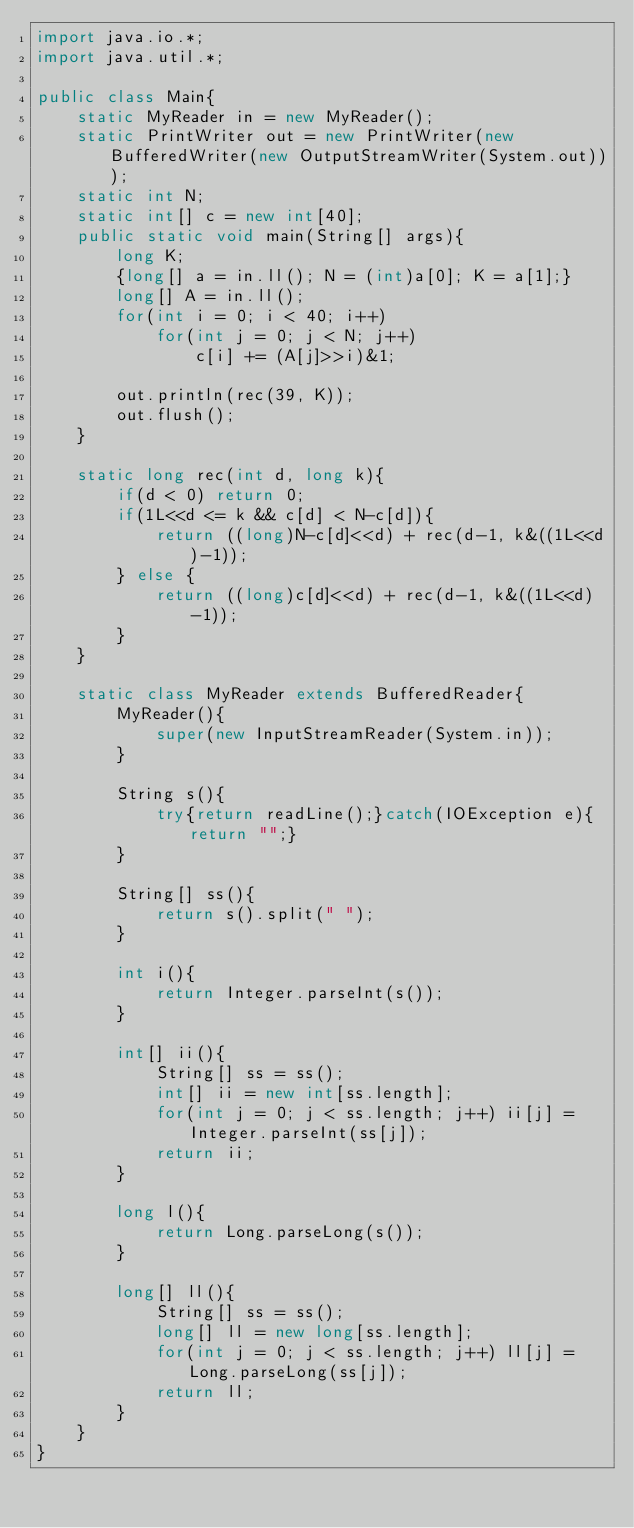<code> <loc_0><loc_0><loc_500><loc_500><_Java_>import java.io.*;
import java.util.*;

public class Main{
    static MyReader in = new MyReader();
    static PrintWriter out = new PrintWriter(new BufferedWriter(new OutputStreamWriter(System.out)));
    static int N;
    static int[] c = new int[40];
    public static void main(String[] args){
        long K;
        {long[] a = in.ll(); N = (int)a[0]; K = a[1];}
        long[] A = in.ll();
        for(int i = 0; i < 40; i++)
            for(int j = 0; j < N; j++)
                c[i] += (A[j]>>i)&1;

        out.println(rec(39, K));
        out.flush();
    }

    static long rec(int d, long k){
        if(d < 0) return 0;
        if(1L<<d <= k && c[d] < N-c[d]){
            return ((long)N-c[d]<<d) + rec(d-1, k&((1L<<d)-1));
        } else {
            return ((long)c[d]<<d) + rec(d-1, k&((1L<<d)-1));
        }
    }

    static class MyReader extends BufferedReader{
        MyReader(){
            super(new InputStreamReader(System.in));
        }

        String s(){
            try{return readLine();}catch(IOException e){return "";}
        }

        String[] ss(){
            return s().split(" ");
        }

        int i(){
            return Integer.parseInt(s());
        }

        int[] ii(){
            String[] ss = ss();
            int[] ii = new int[ss.length];
            for(int j = 0; j < ss.length; j++) ii[j] = Integer.parseInt(ss[j]);
            return ii;
        }

        long l(){
            return Long.parseLong(s());
        }

        long[] ll(){
            String[] ss = ss();
            long[] ll = new long[ss.length];
            for(int j = 0; j < ss.length; j++) ll[j] = Long.parseLong(ss[j]);
            return ll;
        }
    }
}
</code> 